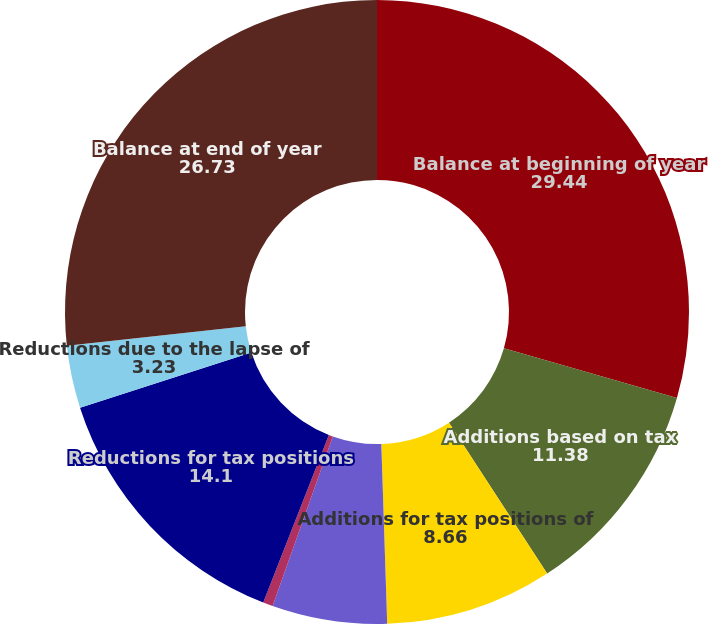Convert chart to OTSL. <chart><loc_0><loc_0><loc_500><loc_500><pie_chart><fcel>Balance at beginning of year<fcel>Additions based on tax<fcel>Additions for tax positions of<fcel>Impact of changes in exchange<fcel>Settlements with tax<fcel>Reductions for tax positions<fcel>Reductions due to the lapse of<fcel>Balance at end of year<nl><fcel>29.44%<fcel>11.38%<fcel>8.66%<fcel>5.95%<fcel>0.51%<fcel>14.1%<fcel>3.23%<fcel>26.73%<nl></chart> 